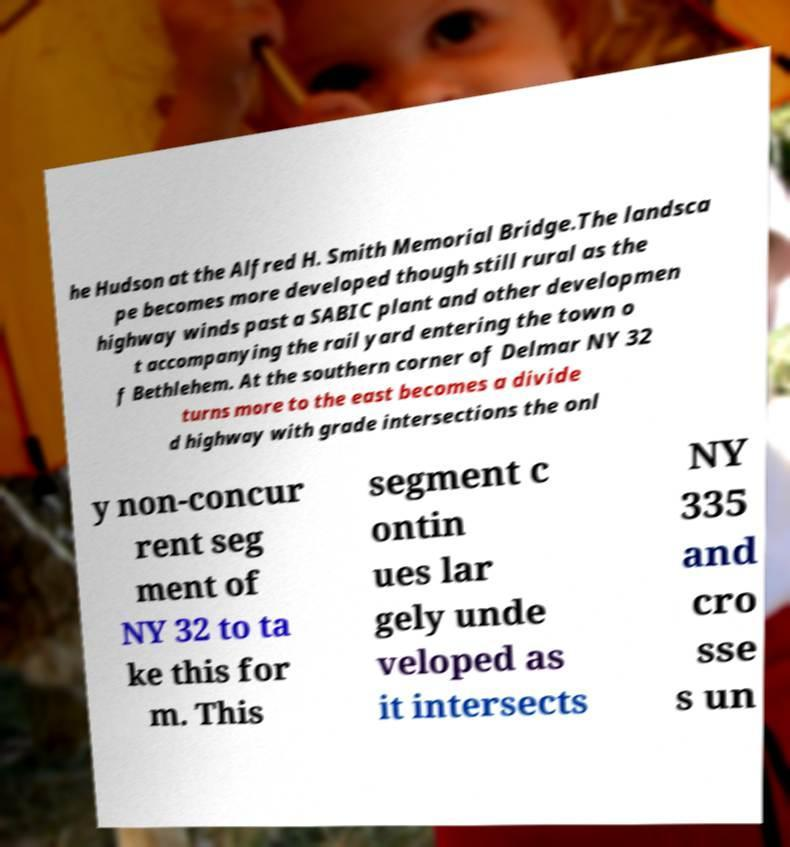Could you extract and type out the text from this image? he Hudson at the Alfred H. Smith Memorial Bridge.The landsca pe becomes more developed though still rural as the highway winds past a SABIC plant and other developmen t accompanying the rail yard entering the town o f Bethlehem. At the southern corner of Delmar NY 32 turns more to the east becomes a divide d highway with grade intersections the onl y non-concur rent seg ment of NY 32 to ta ke this for m. This segment c ontin ues lar gely unde veloped as it intersects NY 335 and cro sse s un 